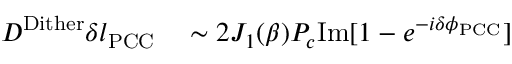<formula> <loc_0><loc_0><loc_500><loc_500>\begin{array} { r l } { D ^ { D i t h e r } \delta l _ { P C C } } & \sim 2 J _ { 1 } ( \beta ) P _ { c } I m [ 1 - e ^ { - i \delta \phi _ { P C C } } ] } \end{array}</formula> 